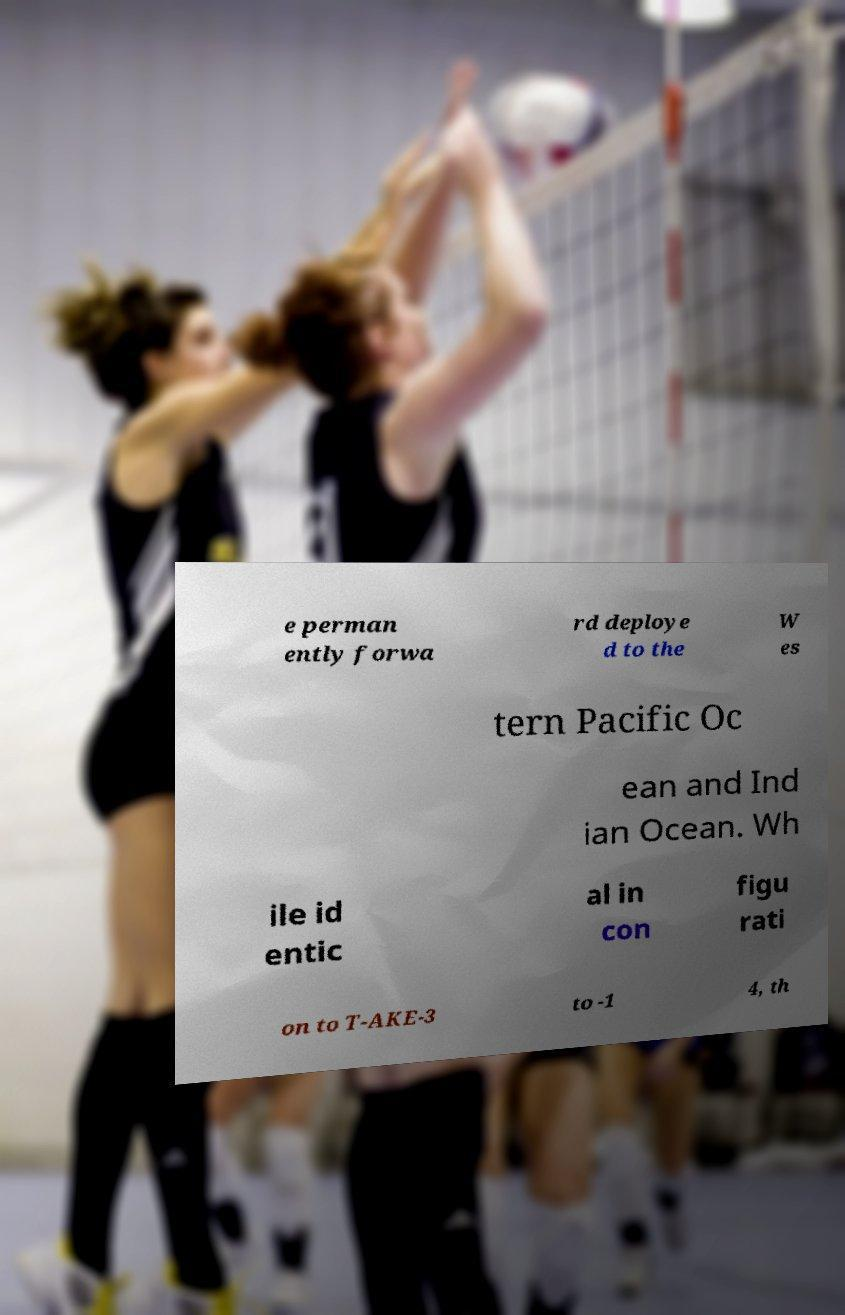There's text embedded in this image that I need extracted. Can you transcribe it verbatim? e perman ently forwa rd deploye d to the W es tern Pacific Oc ean and Ind ian Ocean. Wh ile id entic al in con figu rati on to T-AKE-3 to -1 4, th 